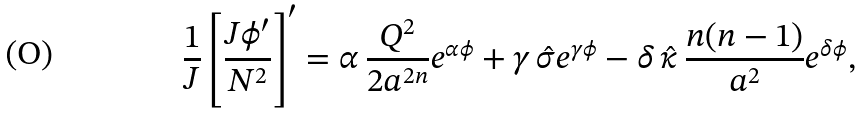<formula> <loc_0><loc_0><loc_500><loc_500>\frac { 1 } { J } \left [ \frac { J \phi ^ { \prime } } { N ^ { 2 } } \right ] ^ { \prime } = \alpha \, \frac { Q ^ { 2 } } { 2 a ^ { 2 n } } e ^ { \alpha \phi } + \gamma \, \hat { \sigma } e ^ { \gamma \phi } - \delta \, \hat { \kappa } \, \frac { n ( n - 1 ) } { a ^ { 2 } } e ^ { \delta \phi } ,</formula> 